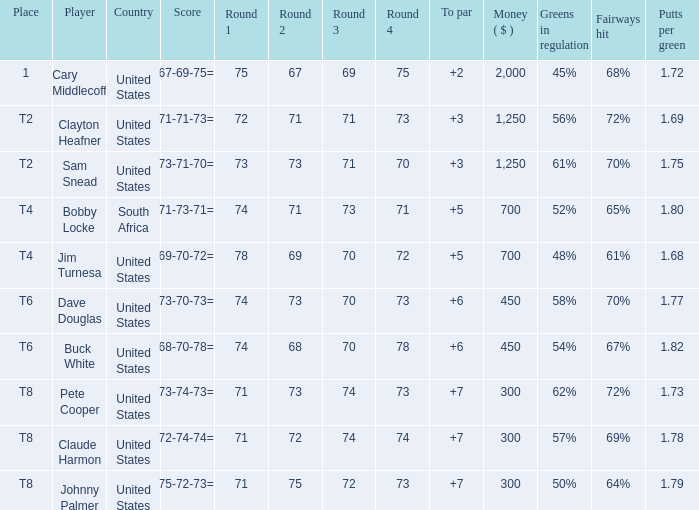What Country is Player Sam Snead with a To par of less than 5 from? United States. 